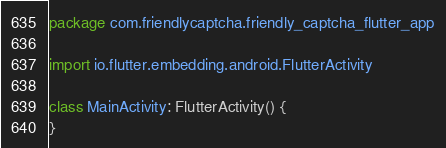<code> <loc_0><loc_0><loc_500><loc_500><_Kotlin_>package com.friendlycaptcha.friendly_captcha_flutter_app

import io.flutter.embedding.android.FlutterActivity

class MainActivity: FlutterActivity() {
}
</code> 